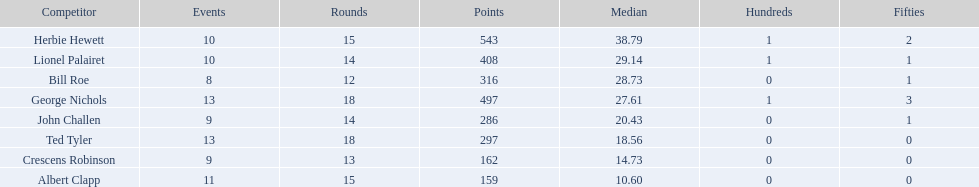How many players played more than 10 matches? 3. 